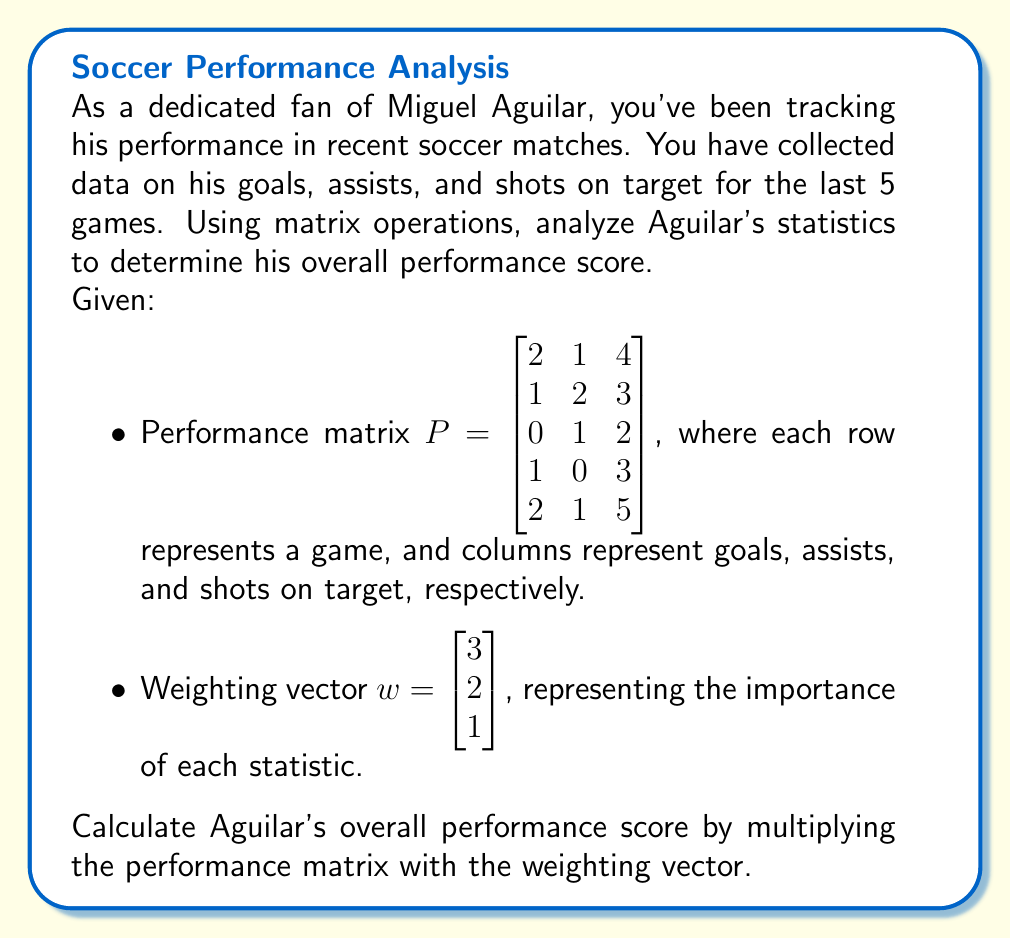Solve this math problem. To solve this problem, we need to perform matrix multiplication between the performance matrix $P$ and the weighting vector $w$. This will give us a column vector representing Aguilar's weighted performance scores for each game.

Step 1: Set up the matrix multiplication
$$Pw = \begin{bmatrix} 2 & 1 & 4 \\ 1 & 2 & 3 \\ 0 & 1 & 2 \\ 1 & 0 & 3 \\ 2 & 1 & 5 \end{bmatrix} \begin{bmatrix} 3 \\ 2 \\ 1 \end{bmatrix}$$

Step 2: Perform the matrix multiplication
For each row of $P$, we multiply by the corresponding element of $w$ and sum the results:

Game 1: $(2 \times 3) + (1 \times 2) + (4 \times 1) = 6 + 2 + 4 = 12$
Game 2: $(1 \times 3) + (2 \times 2) + (3 \times 1) = 3 + 4 + 3 = 10$
Game 3: $(0 \times 3) + (1 \times 2) + (2 \times 1) = 0 + 2 + 2 = 4$
Game 4: $(1 \times 3) + (0 \times 2) + (3 \times 1) = 3 + 0 + 3 = 6$
Game 5: $(2 \times 3) + (1 \times 2) + (5 \times 1) = 6 + 2 + 5 = 13$

Step 3: Write the result as a column vector
$$Pw = \begin{bmatrix} 12 \\ 10 \\ 4 \\ 6 \\ 13 \end{bmatrix}$$

This column vector represents Aguilar's weighted performance scores for each of the 5 games.

Step 4: Calculate the overall performance score
To get a single overall performance score, we can sum the elements of the resulting vector:

$12 + 10 + 4 + 6 + 13 = 45$

Therefore, Miguel Aguilar's overall performance score for the 5 games is 45.
Answer: Miguel Aguilar's overall performance score is 45. 